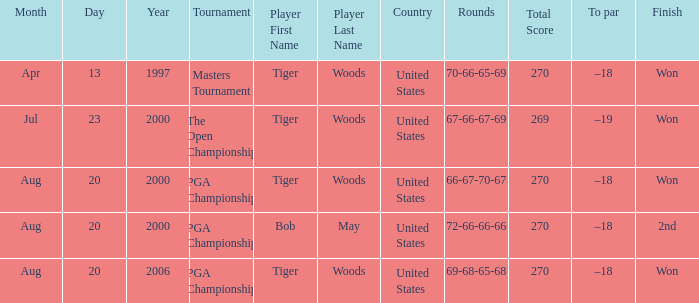What players finished 2nd? Bob May. 